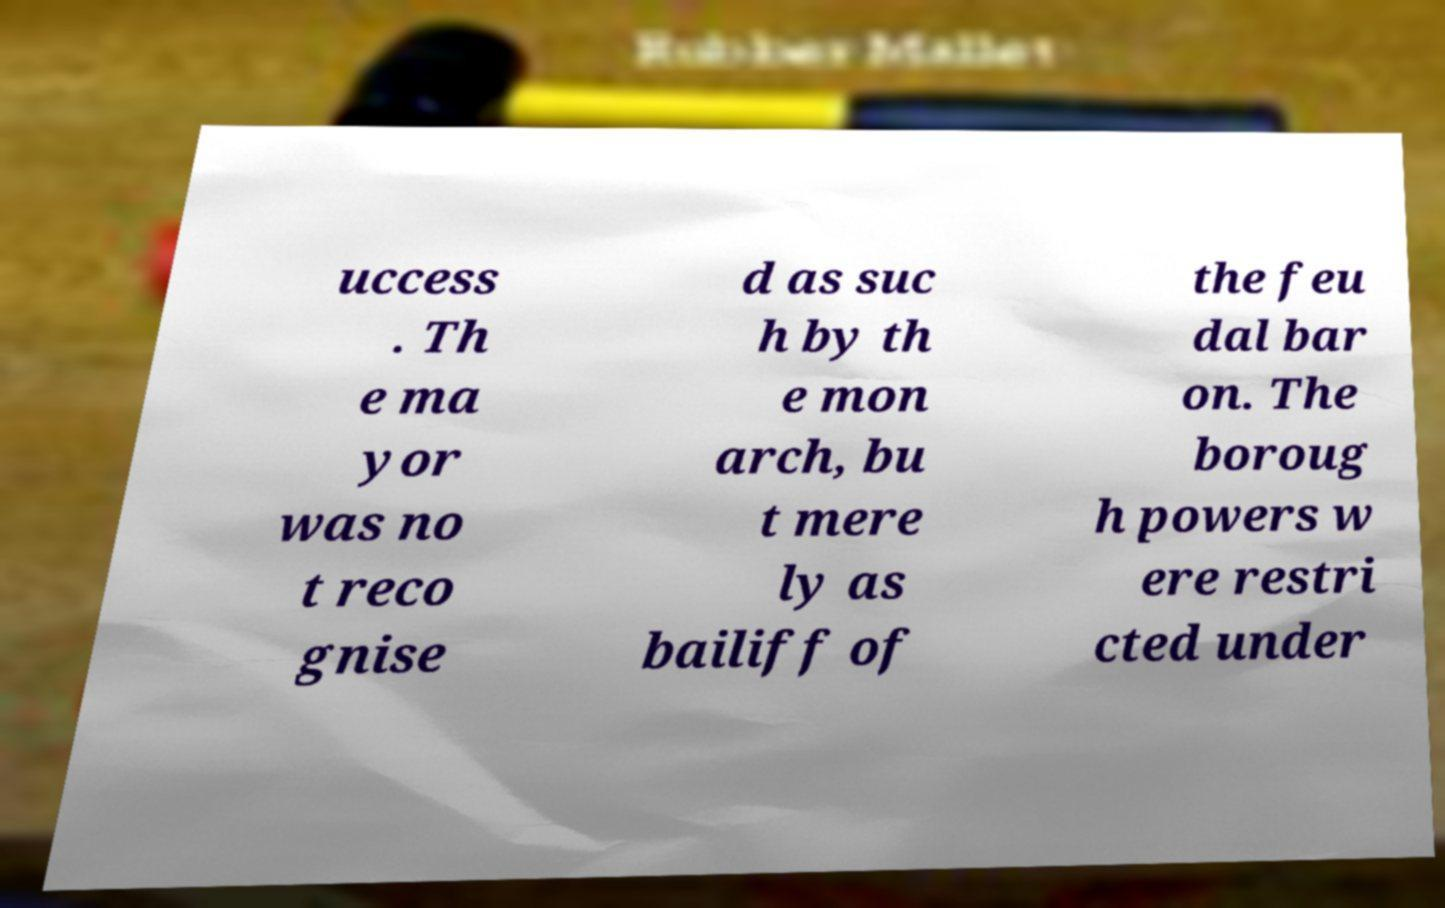Please identify and transcribe the text found in this image. uccess . Th e ma yor was no t reco gnise d as suc h by th e mon arch, bu t mere ly as bailiff of the feu dal bar on. The boroug h powers w ere restri cted under 